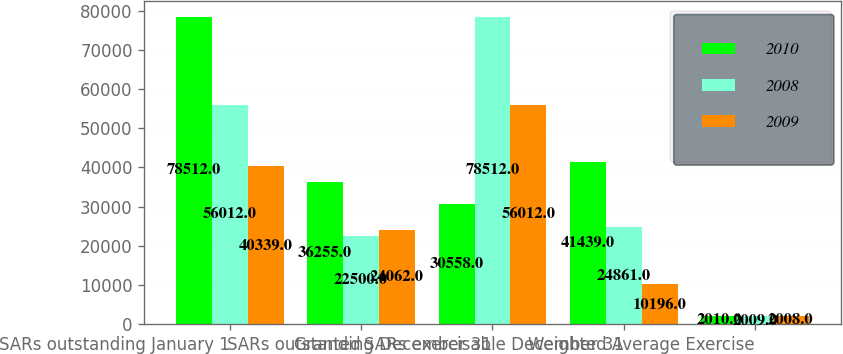<chart> <loc_0><loc_0><loc_500><loc_500><stacked_bar_chart><ecel><fcel>SARs outstanding January 1<fcel>Granted<fcel>SARs outstanding December 31<fcel>SARs exercisable December 31<fcel>Weighted Average Exercise<nl><fcel>2010<fcel>78512<fcel>36255<fcel>30558<fcel>41439<fcel>2010<nl><fcel>2008<fcel>56012<fcel>22500<fcel>78512<fcel>24861<fcel>2009<nl><fcel>2009<fcel>40339<fcel>24062<fcel>56012<fcel>10196<fcel>2008<nl></chart> 